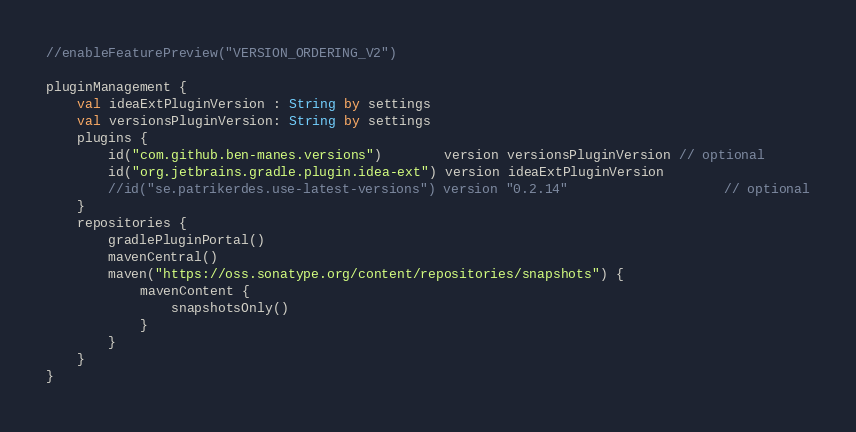<code> <loc_0><loc_0><loc_500><loc_500><_Kotlin_>//enableFeaturePreview("VERSION_ORDERING_V2")

pluginManagement {
    val ideaExtPluginVersion : String by settings
    val versionsPluginVersion: String by settings
    plugins {
        id("com.github.ben-manes.versions")        version versionsPluginVersion // optional
        id("org.jetbrains.gradle.plugin.idea-ext") version ideaExtPluginVersion
        //id("se.patrikerdes.use-latest-versions") version "0.2.14"                    // optional
    }
    repositories {
        gradlePluginPortal()
        mavenCentral()
        maven("https://oss.sonatype.org/content/repositories/snapshots") {
            mavenContent {
                snapshotsOnly()
            }
        }
    }
}
</code> 